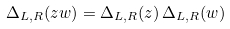Convert formula to latex. <formula><loc_0><loc_0><loc_500><loc_500>\Delta _ { L , R } ( z w ) = \Delta _ { L , R } ( z ) \, \Delta _ { L , R } ( w )</formula> 